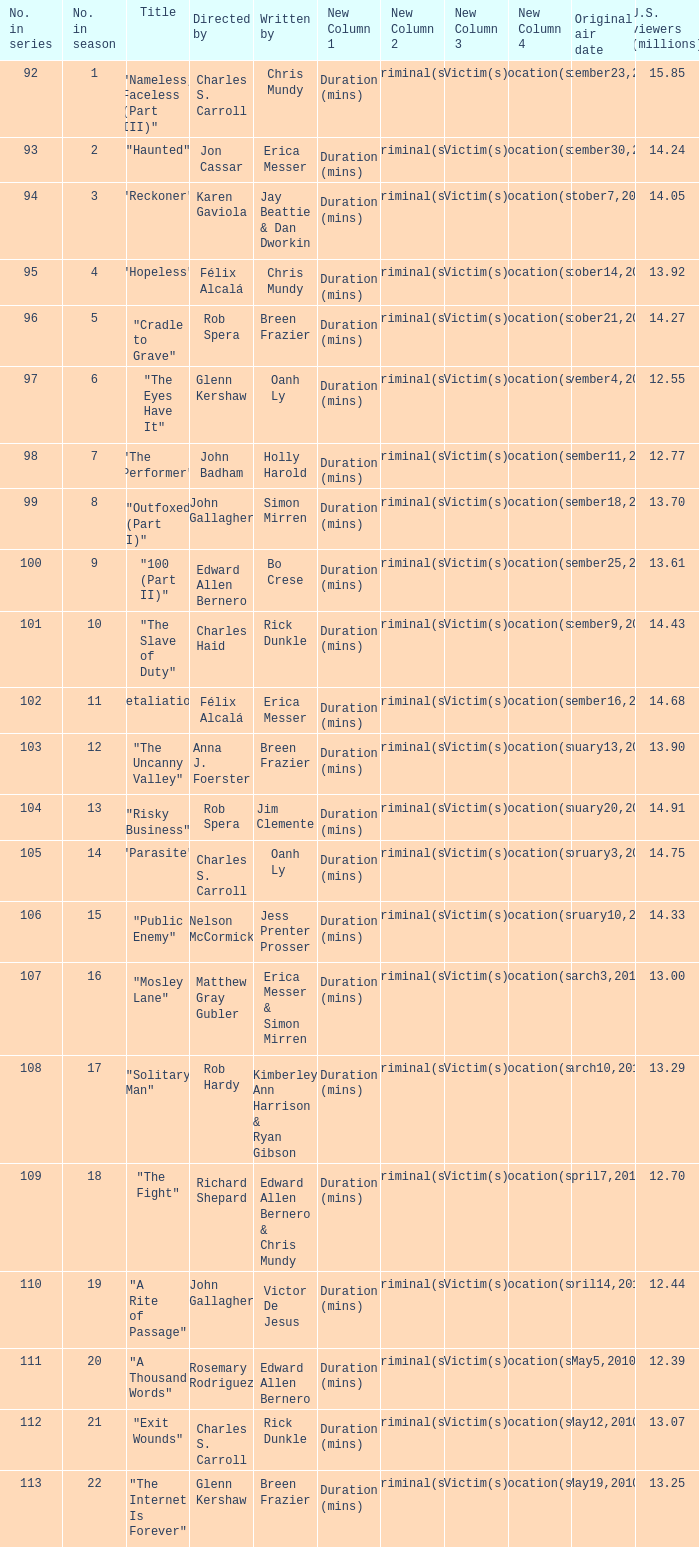What number(s) in the series was written by bo crese? 100.0. 